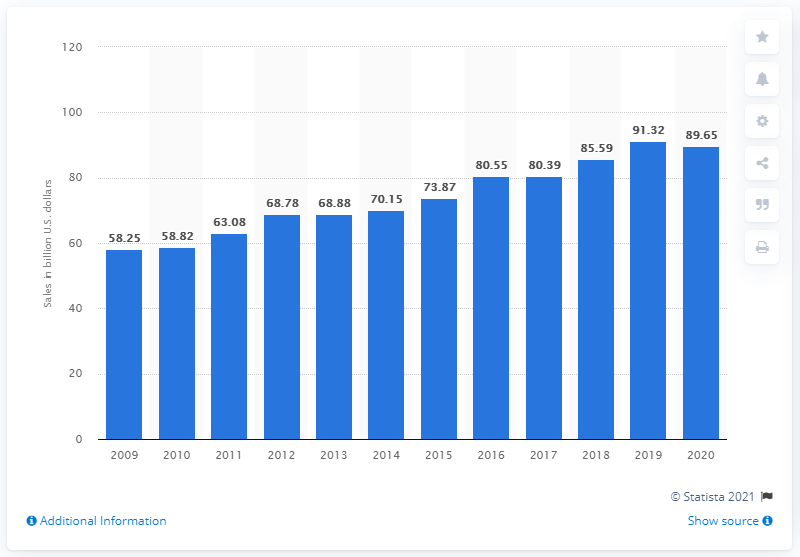Give some essential details in this illustration. In 2020, the sales of state lotteries in the United States totaled approximately $89.65 billion. 